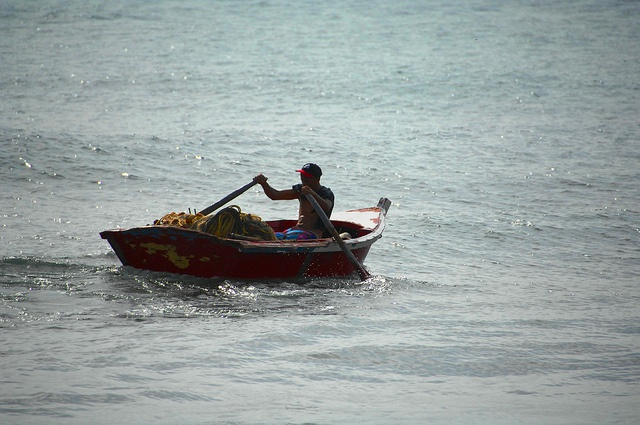Describe the objects in this image and their specific colors. I can see boat in gray, black, lightgray, and darkgray tones and people in gray, black, maroon, and darkgray tones in this image. 